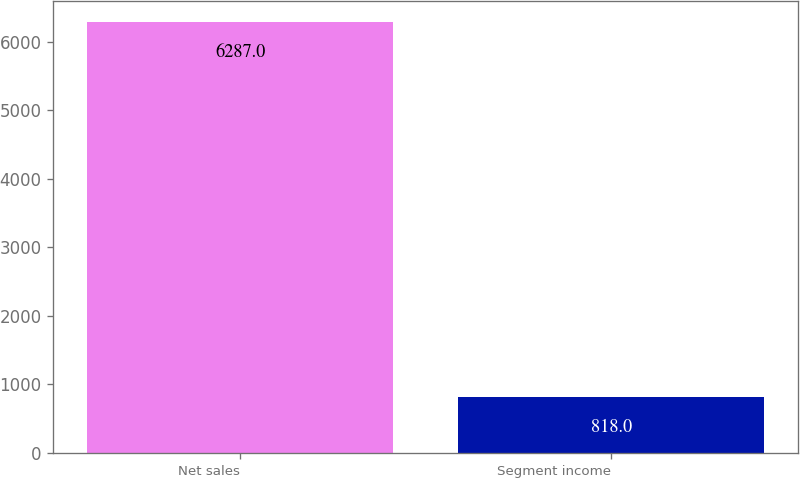Convert chart to OTSL. <chart><loc_0><loc_0><loc_500><loc_500><bar_chart><fcel>Net sales<fcel>Segment income<nl><fcel>6287<fcel>818<nl></chart> 